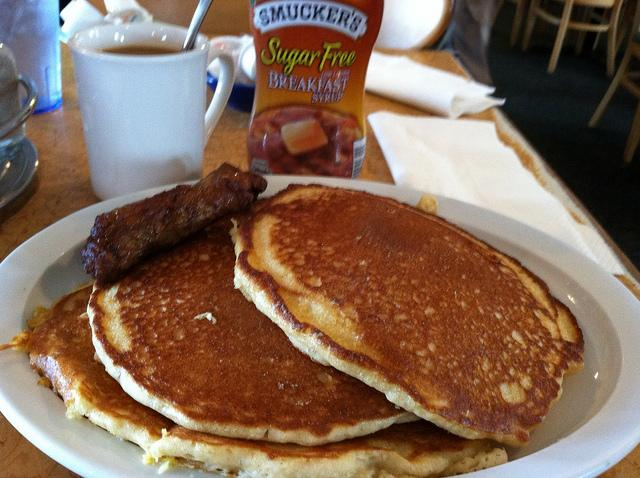What is the Smucker's product replacing? Please explain your reasoning. maple syrup. The bottle is by pancakes to pour onto. 